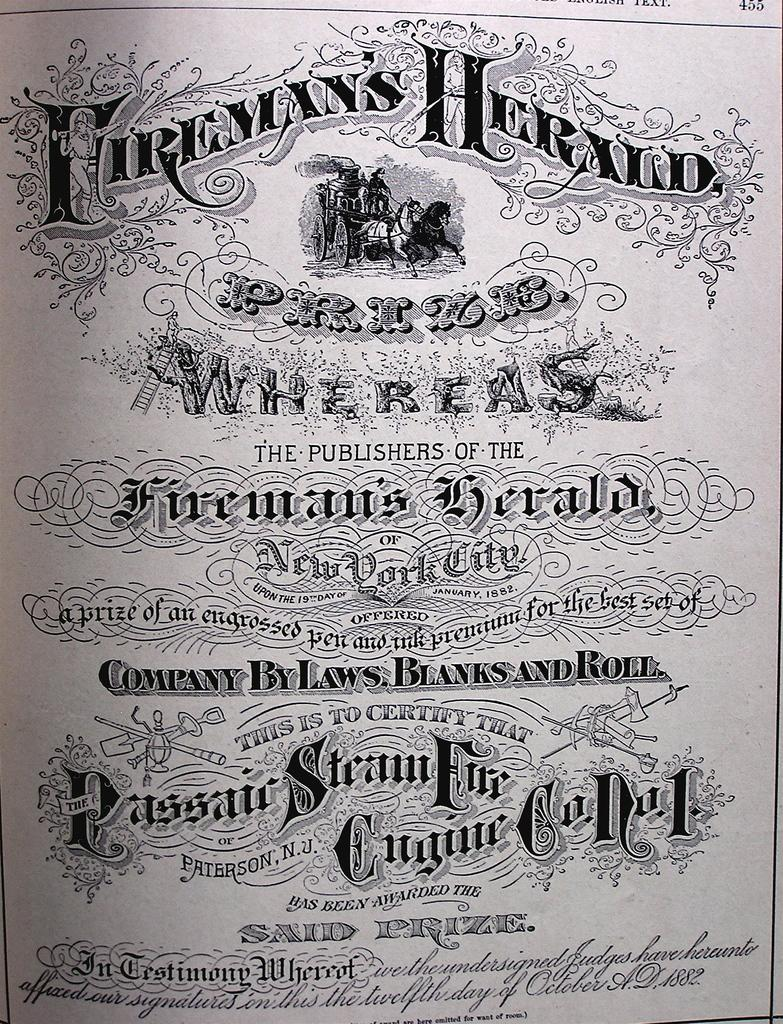<image>
Share a concise interpretation of the image provided. A page of ornate printed text talks about a prize from fireman's herald. 